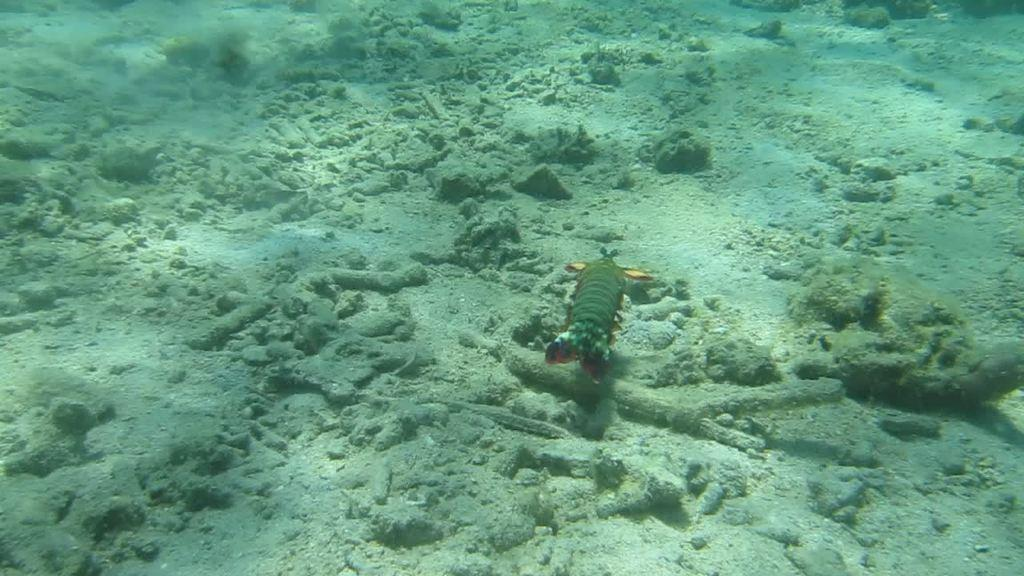What type of animal can be seen in the image? There is a fish in the water in the image. Can you describe the environment in which the fish is located? The fish is located in water. What team is the calculator supporting in the image? There is no calculator present in the image, and therefore no team support can be observed. 